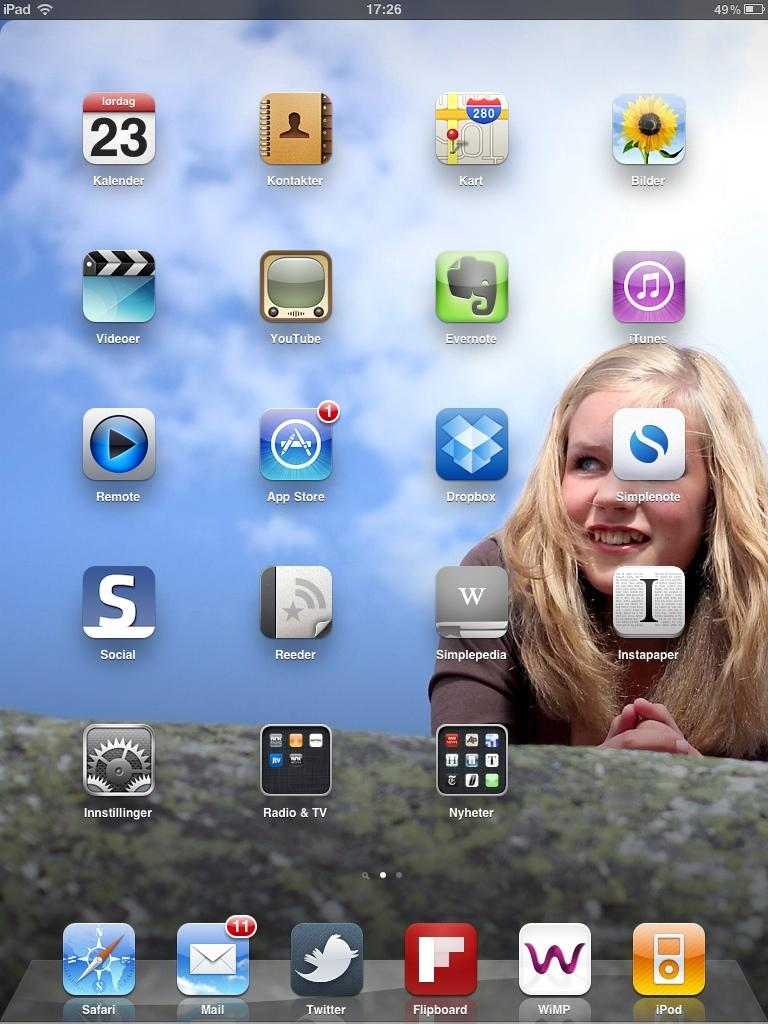<image>
Create a compact narrative representing the image presented. The homescreen for someones device shows they have 11 new emails. 